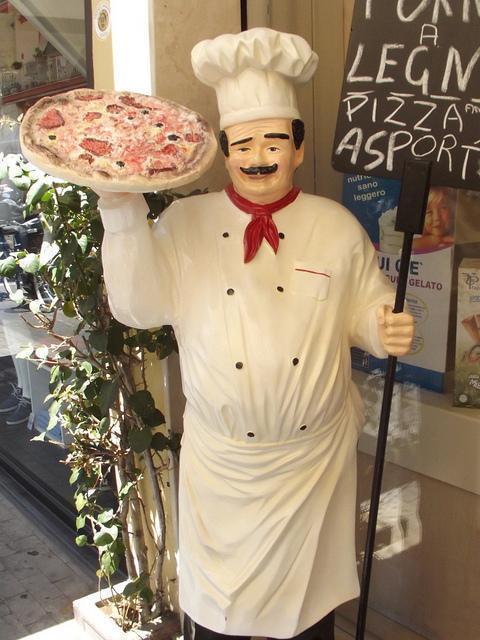What is the statue holding?
Select the correct answer and articulate reasoning with the following format: 'Answer: answer
Rationale: rationale.'
Options: Torch, pizza, television, plunger. Answer: pizza.
Rationale: The statue is of a chef holding a pan with pizza on it. 